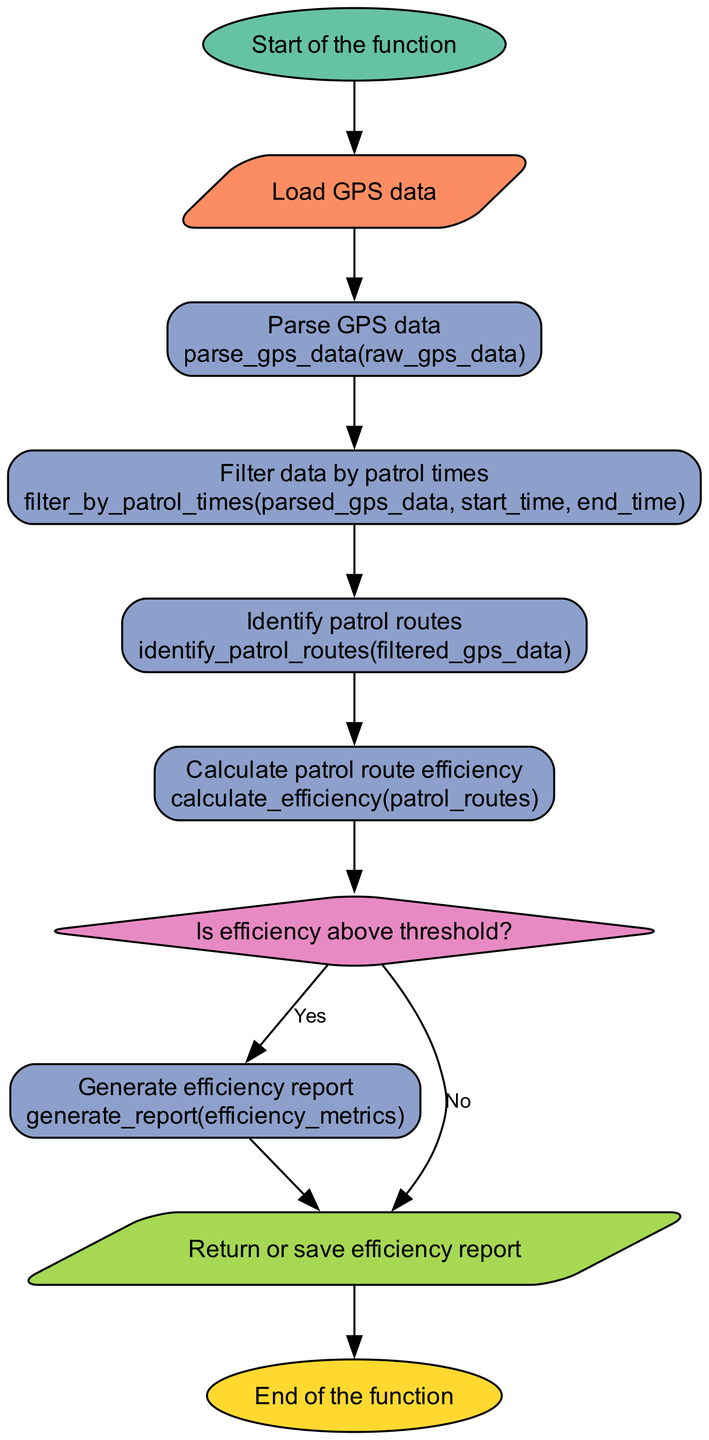What is the first step in the function? The diagram starts with the node labeled "Start of the function." This indicates the initiation point of the process.
Answer: Start of the function How many processes are there in the diagram? By counting the nodes labeled as "process," we find there are four such nodes in the diagram.
Answer: Four What function is used to calculate patrol route efficiency? The specific function designated for calculating efficiency is "calculate_efficiency." This can be found in the corresponding process node within the diagram.
Answer: calculate_efficiency What happens if the efficiency is below the threshold? The diagram shows a decision node that splits the flow based on whether the efficiency metrics are above the threshold or not. If it is not, the process does not generate a report.
Answer: Generate efficiency report What is the last action taken in this function? The final action is represented by the "Return or save efficiency report" node. This indicates that after the report is generated, it will be returned or saved.
Answer: Return or save efficiency report What type of node follows the "Identify patrol routes" process? After the "Identify patrol routes" process node, the next node is a process node for "Calculate patrol route efficiency". This indicates a sequential flow of processing data.
Answer: Calculate patrol route efficiency Which data is used to filter by patrol times? The input data required for filtering is the "parsed_gps_data" along with "start_time" and "end_time" parameters. The initial process provides this data to the filtering step.
Answer: parsed_gps_data How many decision points are present in the diagram? There is a single decision point in the flowchart indicated by the diamond-shaped node, which assesses if the efficiency metrics exceed the threshold.
Answer: One What is the output of the "Generate efficiency report" process? The output from the "Generate efficiency report" process is labeled as "efficiency_report," indicating the final report generated from the efficiency metrics collected earlier in the function.
Answer: efficiency_report 